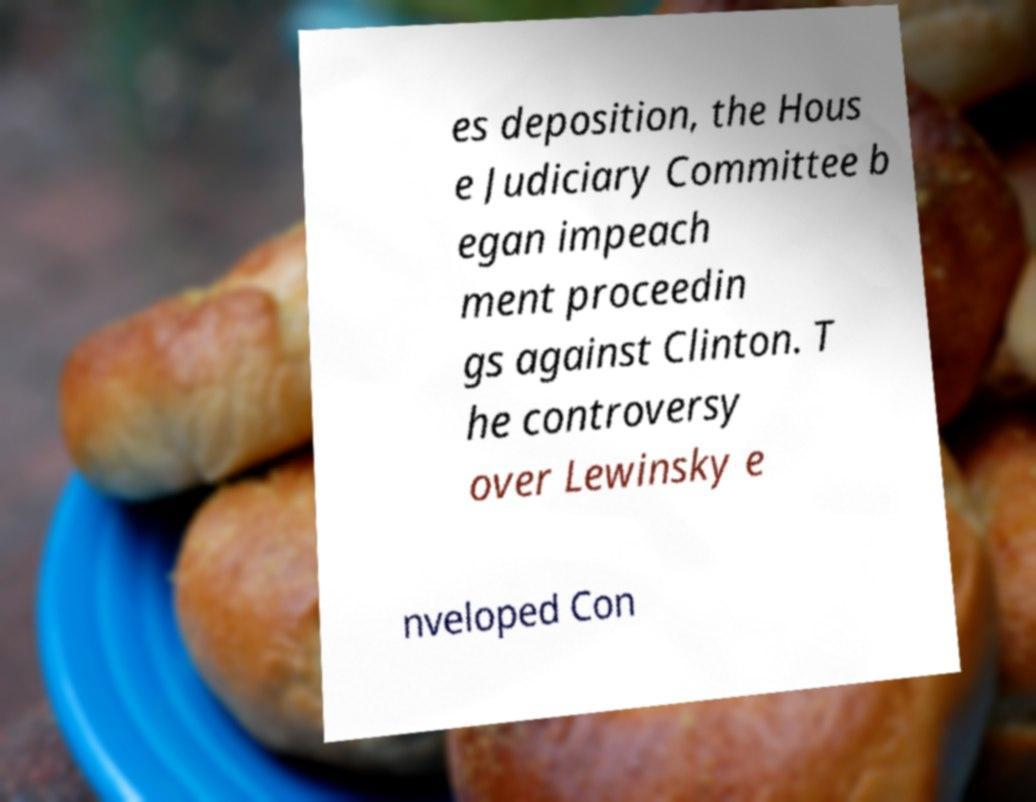Could you extract and type out the text from this image? es deposition, the Hous e Judiciary Committee b egan impeach ment proceedin gs against Clinton. T he controversy over Lewinsky e nveloped Con 